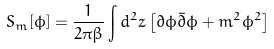<formula> <loc_0><loc_0><loc_500><loc_500>S _ { m } [ \phi ] = \frac { 1 } { 2 \pi \beta } \int d ^ { 2 } z \left [ \partial \phi \bar { \partial } \phi + m ^ { 2 } \phi ^ { 2 } \right ]</formula> 